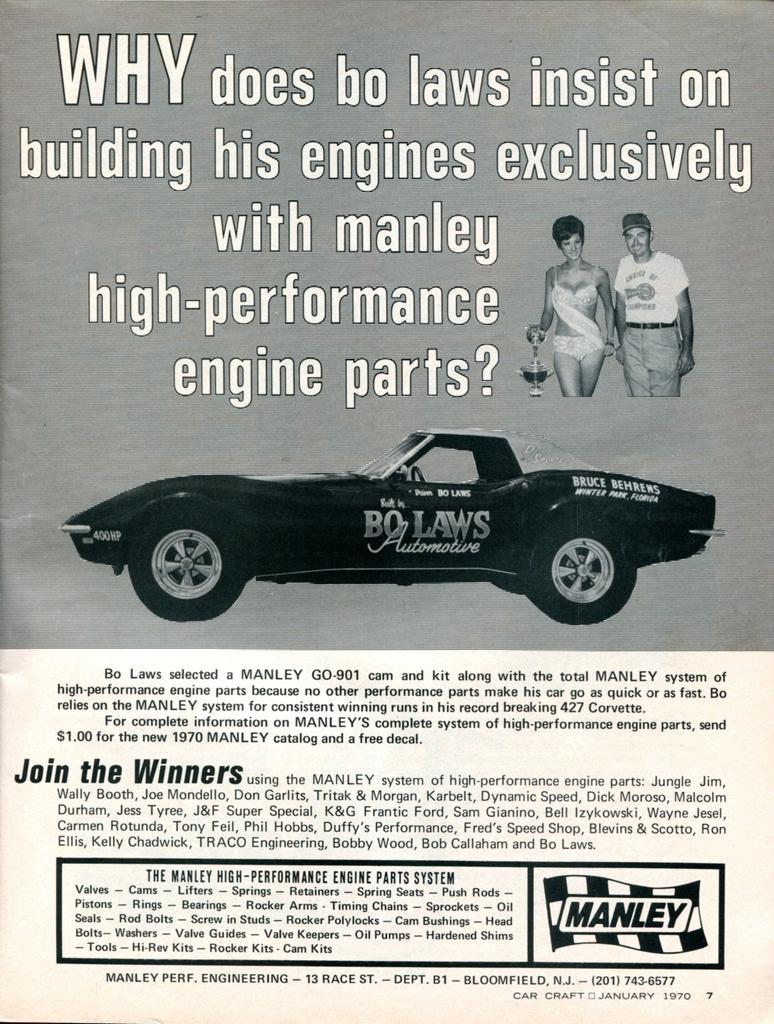Could you give a brief overview of what you see in this image? In this image we can see a paper. In the center of the paper there is a car. At the bottom and top there is text written. On the right side there are two people standing. 